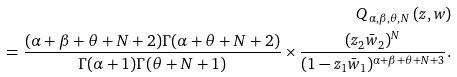<formula> <loc_0><loc_0><loc_500><loc_500>Q _ { \alpha , \beta , \theta , N } \left ( z , w \right ) \\ = \frac { ( \alpha + \beta + \theta + N + 2 ) \Gamma ( \alpha + \theta + N + 2 ) } { \Gamma ( \alpha + 1 ) \Gamma ( \theta + N + 1 ) } \times \frac { ( z _ { 2 } \bar { w } _ { 2 } ) ^ { N } } { ( 1 - z _ { 1 } \bar { w } _ { 1 } ) ^ { \alpha + \beta + \theta + N + 3 } } .</formula> 